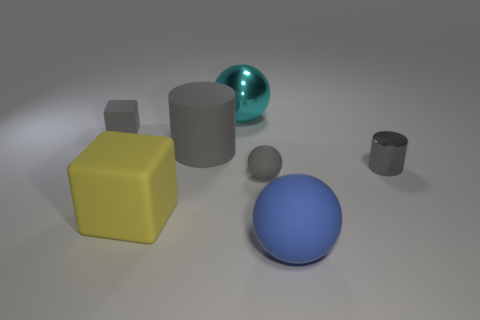What shape is the large object that is the same color as the tiny metal cylinder?
Keep it short and to the point. Cylinder. What number of objects are either matte spheres in front of the gray rubber sphere or tiny gray rubber objects that are behind the small gray matte ball?
Your answer should be compact. 2. Are there any other things that are the same shape as the blue matte object?
Your answer should be compact. Yes. Is the color of the block that is right of the gray rubber block the same as the small rubber thing in front of the large rubber cylinder?
Provide a succinct answer. No. How many rubber things are either large purple cylinders or gray things?
Your response must be concise. 3. Are there any other things that have the same size as the blue thing?
Offer a very short reply. Yes. There is a tiny gray rubber thing that is to the left of the matte sphere that is behind the large rubber ball; what is its shape?
Ensure brevity in your answer.  Cube. Is the material of the block that is on the right side of the small gray cube the same as the tiny gray thing to the left of the tiny gray ball?
Offer a very short reply. Yes. How many big gray matte cylinders are on the left side of the big sphere in front of the tiny block?
Provide a succinct answer. 1. Does the gray object on the right side of the large blue matte ball have the same shape as the metallic object that is left of the big blue thing?
Your response must be concise. No. 